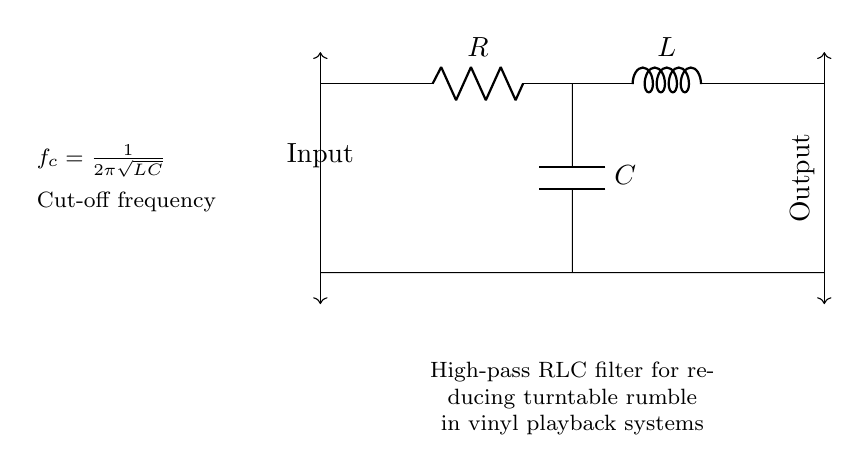What components are in the circuit? The circuit includes a resistor, an inductor, and a capacitor. These components are clearly labeled in the diagram.
Answer: Resistor, inductor, capacitor What is the configuration of the circuit? The components are configured in series, as indicated by the connections from one component to the next without any branches.
Answer: Series What is the cutoff frequency formula shown in the diagram? The formula displayed is f_c = 1/(2π√(LC)), which relates the cutoff frequency to the values of the inductor and capacitor.
Answer: f_c = 1/(2π√(LC)) How does this filter type affect low-frequency signals? As a high-pass filter, it attenuates low-frequency signals, allowing only higher frequencies to pass through to the output.
Answer: Attenuates What is the purpose of the high-pass RLC filter? The primary purpose is to reduce turntable rumble, which refers to unwanted low-frequency noise during vinyl playback.
Answer: Reduce turntable rumble What effect does an increase in the capacitance have on the cutoff frequency? Increasing the capacitance will decrease the cutoff frequency, which allows lower frequencies to pass, counteracting the filter's purpose.
Answer: Decreases cutoff frequency What term describes the connection points labeled 'Input' and 'Output'? These points are the terminals where the audio signal enters the filter and exits after processing, respectively.
Answer: Terminals 